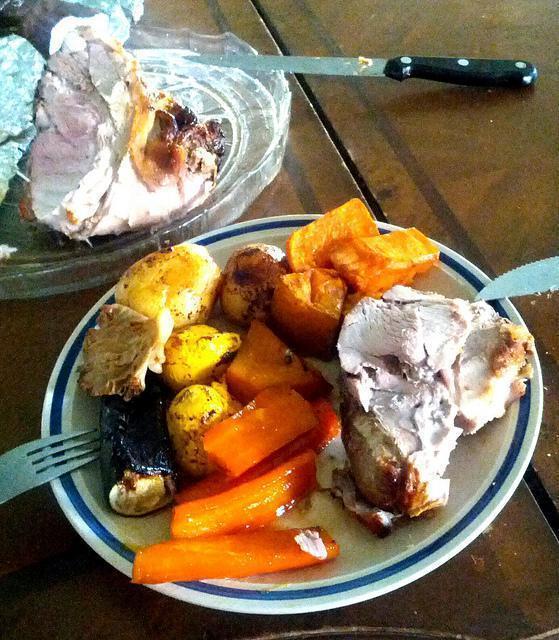How have these vegetables been cooked?
From the following four choices, select the correct answer to address the question.
Options: Roasted, fried, baked, boiled. Roasted. 